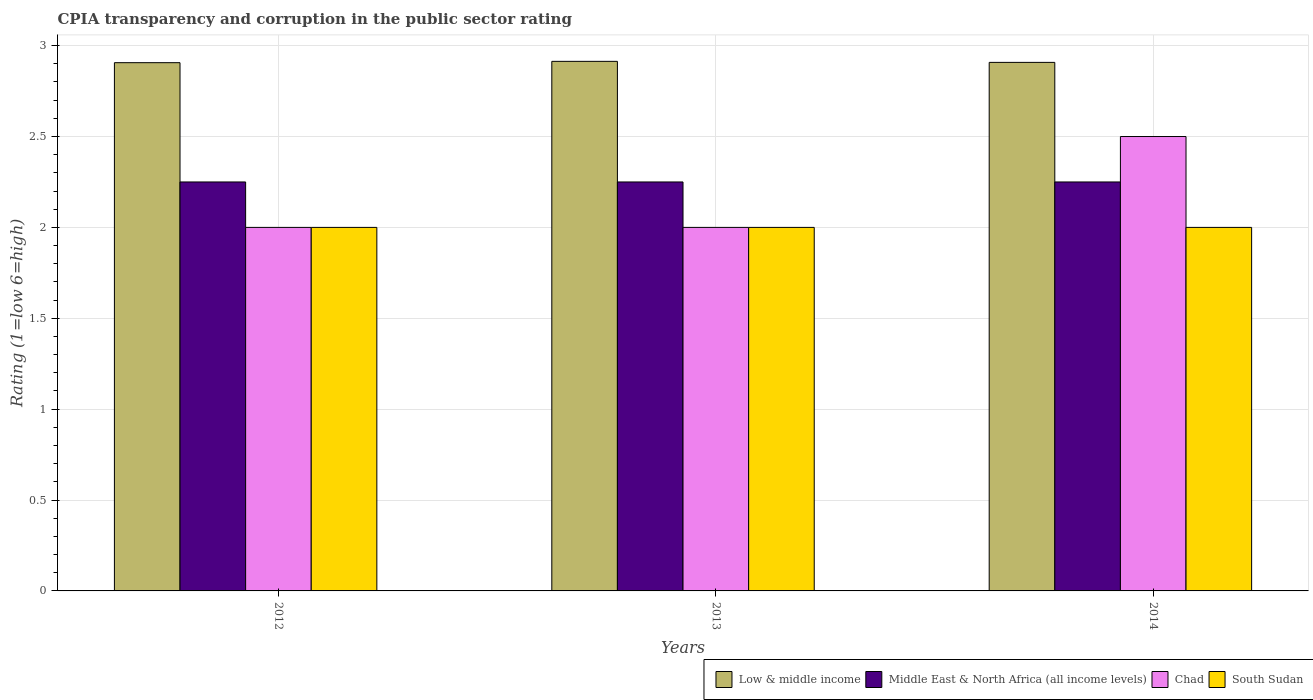How many groups of bars are there?
Give a very brief answer. 3. Are the number of bars on each tick of the X-axis equal?
Your answer should be very brief. Yes. How many bars are there on the 3rd tick from the right?
Your answer should be compact. 4. In how many cases, is the number of bars for a given year not equal to the number of legend labels?
Give a very brief answer. 0. Across all years, what is the maximum CPIA rating in South Sudan?
Your response must be concise. 2. Across all years, what is the minimum CPIA rating in South Sudan?
Ensure brevity in your answer.  2. In which year was the CPIA rating in Chad maximum?
Provide a short and direct response. 2014. In which year was the CPIA rating in Chad minimum?
Your answer should be very brief. 2012. What is the difference between the CPIA rating in Low & middle income in 2012 and the CPIA rating in Chad in 2013?
Keep it short and to the point. 0.91. What is the average CPIA rating in Chad per year?
Give a very brief answer. 2.17. In the year 2013, what is the difference between the CPIA rating in Low & middle income and CPIA rating in South Sudan?
Your answer should be very brief. 0.91. Is the CPIA rating in Middle East & North Africa (all income levels) in 2013 less than that in 2014?
Your response must be concise. No. What is the difference between the highest and the lowest CPIA rating in Low & middle income?
Provide a succinct answer. 0.01. In how many years, is the CPIA rating in Low & middle income greater than the average CPIA rating in Low & middle income taken over all years?
Your answer should be compact. 1. Is it the case that in every year, the sum of the CPIA rating in Middle East & North Africa (all income levels) and CPIA rating in Chad is greater than the sum of CPIA rating in South Sudan and CPIA rating in Low & middle income?
Make the answer very short. Yes. What does the 4th bar from the left in 2013 represents?
Your answer should be very brief. South Sudan. What does the 1st bar from the right in 2013 represents?
Your answer should be very brief. South Sudan. Is it the case that in every year, the sum of the CPIA rating in South Sudan and CPIA rating in Low & middle income is greater than the CPIA rating in Chad?
Offer a very short reply. Yes. Are all the bars in the graph horizontal?
Your answer should be very brief. No. How many years are there in the graph?
Your answer should be very brief. 3. What is the difference between two consecutive major ticks on the Y-axis?
Your response must be concise. 0.5. Are the values on the major ticks of Y-axis written in scientific E-notation?
Your answer should be very brief. No. Does the graph contain grids?
Give a very brief answer. Yes. How are the legend labels stacked?
Provide a short and direct response. Horizontal. What is the title of the graph?
Ensure brevity in your answer.  CPIA transparency and corruption in the public sector rating. What is the Rating (1=low 6=high) in Low & middle income in 2012?
Your answer should be very brief. 2.91. What is the Rating (1=low 6=high) of Middle East & North Africa (all income levels) in 2012?
Offer a very short reply. 2.25. What is the Rating (1=low 6=high) of Chad in 2012?
Offer a terse response. 2. What is the Rating (1=low 6=high) in South Sudan in 2012?
Keep it short and to the point. 2. What is the Rating (1=low 6=high) of Low & middle income in 2013?
Offer a terse response. 2.91. What is the Rating (1=low 6=high) in Middle East & North Africa (all income levels) in 2013?
Give a very brief answer. 2.25. What is the Rating (1=low 6=high) of Low & middle income in 2014?
Ensure brevity in your answer.  2.91. What is the Rating (1=low 6=high) in Middle East & North Africa (all income levels) in 2014?
Offer a terse response. 2.25. What is the Rating (1=low 6=high) in Chad in 2014?
Ensure brevity in your answer.  2.5. Across all years, what is the maximum Rating (1=low 6=high) of Low & middle income?
Offer a very short reply. 2.91. Across all years, what is the maximum Rating (1=low 6=high) of Middle East & North Africa (all income levels)?
Keep it short and to the point. 2.25. Across all years, what is the maximum Rating (1=low 6=high) of Chad?
Ensure brevity in your answer.  2.5. Across all years, what is the maximum Rating (1=low 6=high) in South Sudan?
Your answer should be very brief. 2. Across all years, what is the minimum Rating (1=low 6=high) of Low & middle income?
Provide a succinct answer. 2.91. Across all years, what is the minimum Rating (1=low 6=high) in Middle East & North Africa (all income levels)?
Ensure brevity in your answer.  2.25. Across all years, what is the minimum Rating (1=low 6=high) in South Sudan?
Offer a very short reply. 2. What is the total Rating (1=low 6=high) of Low & middle income in the graph?
Offer a terse response. 8.73. What is the total Rating (1=low 6=high) in Middle East & North Africa (all income levels) in the graph?
Keep it short and to the point. 6.75. What is the total Rating (1=low 6=high) of Chad in the graph?
Your response must be concise. 6.5. What is the difference between the Rating (1=low 6=high) of Low & middle income in 2012 and that in 2013?
Your answer should be very brief. -0.01. What is the difference between the Rating (1=low 6=high) of Middle East & North Africa (all income levels) in 2012 and that in 2013?
Offer a very short reply. 0. What is the difference between the Rating (1=low 6=high) in Low & middle income in 2012 and that in 2014?
Offer a terse response. -0. What is the difference between the Rating (1=low 6=high) of Low & middle income in 2013 and that in 2014?
Give a very brief answer. 0.01. What is the difference between the Rating (1=low 6=high) in Middle East & North Africa (all income levels) in 2013 and that in 2014?
Your response must be concise. 0. What is the difference between the Rating (1=low 6=high) in Low & middle income in 2012 and the Rating (1=low 6=high) in Middle East & North Africa (all income levels) in 2013?
Keep it short and to the point. 0.66. What is the difference between the Rating (1=low 6=high) of Low & middle income in 2012 and the Rating (1=low 6=high) of Chad in 2013?
Your response must be concise. 0.91. What is the difference between the Rating (1=low 6=high) in Low & middle income in 2012 and the Rating (1=low 6=high) in South Sudan in 2013?
Your response must be concise. 0.91. What is the difference between the Rating (1=low 6=high) in Middle East & North Africa (all income levels) in 2012 and the Rating (1=low 6=high) in Chad in 2013?
Provide a succinct answer. 0.25. What is the difference between the Rating (1=low 6=high) in Low & middle income in 2012 and the Rating (1=low 6=high) in Middle East & North Africa (all income levels) in 2014?
Your answer should be very brief. 0.66. What is the difference between the Rating (1=low 6=high) in Low & middle income in 2012 and the Rating (1=low 6=high) in Chad in 2014?
Your response must be concise. 0.41. What is the difference between the Rating (1=low 6=high) in Low & middle income in 2012 and the Rating (1=low 6=high) in South Sudan in 2014?
Provide a succinct answer. 0.91. What is the difference between the Rating (1=low 6=high) in Middle East & North Africa (all income levels) in 2012 and the Rating (1=low 6=high) in South Sudan in 2014?
Your answer should be compact. 0.25. What is the difference between the Rating (1=low 6=high) of Low & middle income in 2013 and the Rating (1=low 6=high) of Middle East & North Africa (all income levels) in 2014?
Your response must be concise. 0.66. What is the difference between the Rating (1=low 6=high) in Low & middle income in 2013 and the Rating (1=low 6=high) in Chad in 2014?
Give a very brief answer. 0.41. What is the difference between the Rating (1=low 6=high) of Low & middle income in 2013 and the Rating (1=low 6=high) of South Sudan in 2014?
Provide a short and direct response. 0.91. What is the difference between the Rating (1=low 6=high) in Middle East & North Africa (all income levels) in 2013 and the Rating (1=low 6=high) in South Sudan in 2014?
Offer a terse response. 0.25. What is the average Rating (1=low 6=high) of Low & middle income per year?
Provide a succinct answer. 2.91. What is the average Rating (1=low 6=high) of Middle East & North Africa (all income levels) per year?
Ensure brevity in your answer.  2.25. What is the average Rating (1=low 6=high) in Chad per year?
Provide a succinct answer. 2.17. What is the average Rating (1=low 6=high) in South Sudan per year?
Offer a terse response. 2. In the year 2012, what is the difference between the Rating (1=low 6=high) in Low & middle income and Rating (1=low 6=high) in Middle East & North Africa (all income levels)?
Provide a succinct answer. 0.66. In the year 2012, what is the difference between the Rating (1=low 6=high) in Low & middle income and Rating (1=low 6=high) in Chad?
Provide a short and direct response. 0.91. In the year 2012, what is the difference between the Rating (1=low 6=high) in Low & middle income and Rating (1=low 6=high) in South Sudan?
Your answer should be very brief. 0.91. In the year 2012, what is the difference between the Rating (1=low 6=high) in Middle East & North Africa (all income levels) and Rating (1=low 6=high) in South Sudan?
Your answer should be compact. 0.25. In the year 2013, what is the difference between the Rating (1=low 6=high) in Low & middle income and Rating (1=low 6=high) in Middle East & North Africa (all income levels)?
Your answer should be compact. 0.66. In the year 2013, what is the difference between the Rating (1=low 6=high) in Low & middle income and Rating (1=low 6=high) in Chad?
Offer a very short reply. 0.91. In the year 2013, what is the difference between the Rating (1=low 6=high) in Low & middle income and Rating (1=low 6=high) in South Sudan?
Your response must be concise. 0.91. In the year 2013, what is the difference between the Rating (1=low 6=high) in Chad and Rating (1=low 6=high) in South Sudan?
Your answer should be compact. 0. In the year 2014, what is the difference between the Rating (1=low 6=high) in Low & middle income and Rating (1=low 6=high) in Middle East & North Africa (all income levels)?
Offer a terse response. 0.66. In the year 2014, what is the difference between the Rating (1=low 6=high) of Low & middle income and Rating (1=low 6=high) of Chad?
Provide a succinct answer. 0.41. In the year 2014, what is the difference between the Rating (1=low 6=high) in Low & middle income and Rating (1=low 6=high) in South Sudan?
Make the answer very short. 0.91. In the year 2014, what is the difference between the Rating (1=low 6=high) of Middle East & North Africa (all income levels) and Rating (1=low 6=high) of South Sudan?
Your answer should be compact. 0.25. What is the ratio of the Rating (1=low 6=high) of Chad in 2012 to that in 2013?
Ensure brevity in your answer.  1. What is the ratio of the Rating (1=low 6=high) in South Sudan in 2012 to that in 2013?
Ensure brevity in your answer.  1. What is the ratio of the Rating (1=low 6=high) in Middle East & North Africa (all income levels) in 2012 to that in 2014?
Ensure brevity in your answer.  1. What is the ratio of the Rating (1=low 6=high) of South Sudan in 2012 to that in 2014?
Provide a succinct answer. 1. What is the ratio of the Rating (1=low 6=high) of Middle East & North Africa (all income levels) in 2013 to that in 2014?
Your response must be concise. 1. What is the difference between the highest and the second highest Rating (1=low 6=high) of Low & middle income?
Give a very brief answer. 0.01. What is the difference between the highest and the second highest Rating (1=low 6=high) of Middle East & North Africa (all income levels)?
Give a very brief answer. 0. What is the difference between the highest and the second highest Rating (1=low 6=high) of South Sudan?
Keep it short and to the point. 0. What is the difference between the highest and the lowest Rating (1=low 6=high) of Low & middle income?
Provide a short and direct response. 0.01. What is the difference between the highest and the lowest Rating (1=low 6=high) in South Sudan?
Provide a short and direct response. 0. 